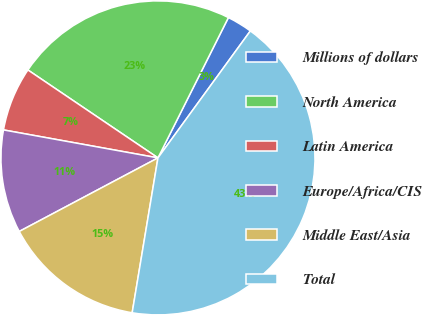<chart> <loc_0><loc_0><loc_500><loc_500><pie_chart><fcel>Millions of dollars<fcel>North America<fcel>Latin America<fcel>Europe/Africa/CIS<fcel>Middle East/Asia<fcel>Total<nl><fcel>2.61%<fcel>22.94%<fcel>6.61%<fcel>10.61%<fcel>14.61%<fcel>42.61%<nl></chart> 